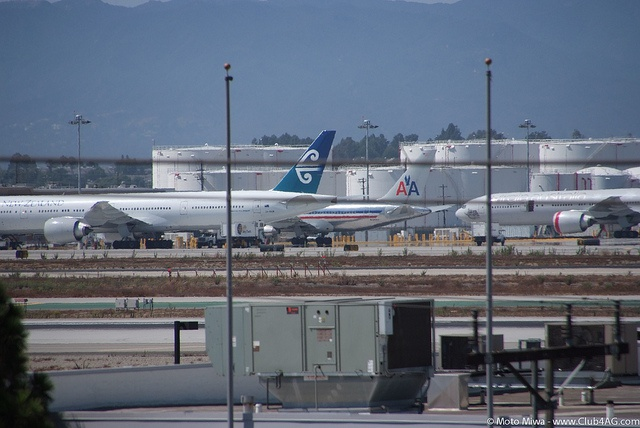Describe the objects in this image and their specific colors. I can see airplane in gray, darkgray, and lightgray tones, airplane in gray, lightgray, and darkgray tones, truck in gray, darkgray, and black tones, truck in gray, darkgray, and black tones, and truck in gray, black, and darkblue tones in this image. 